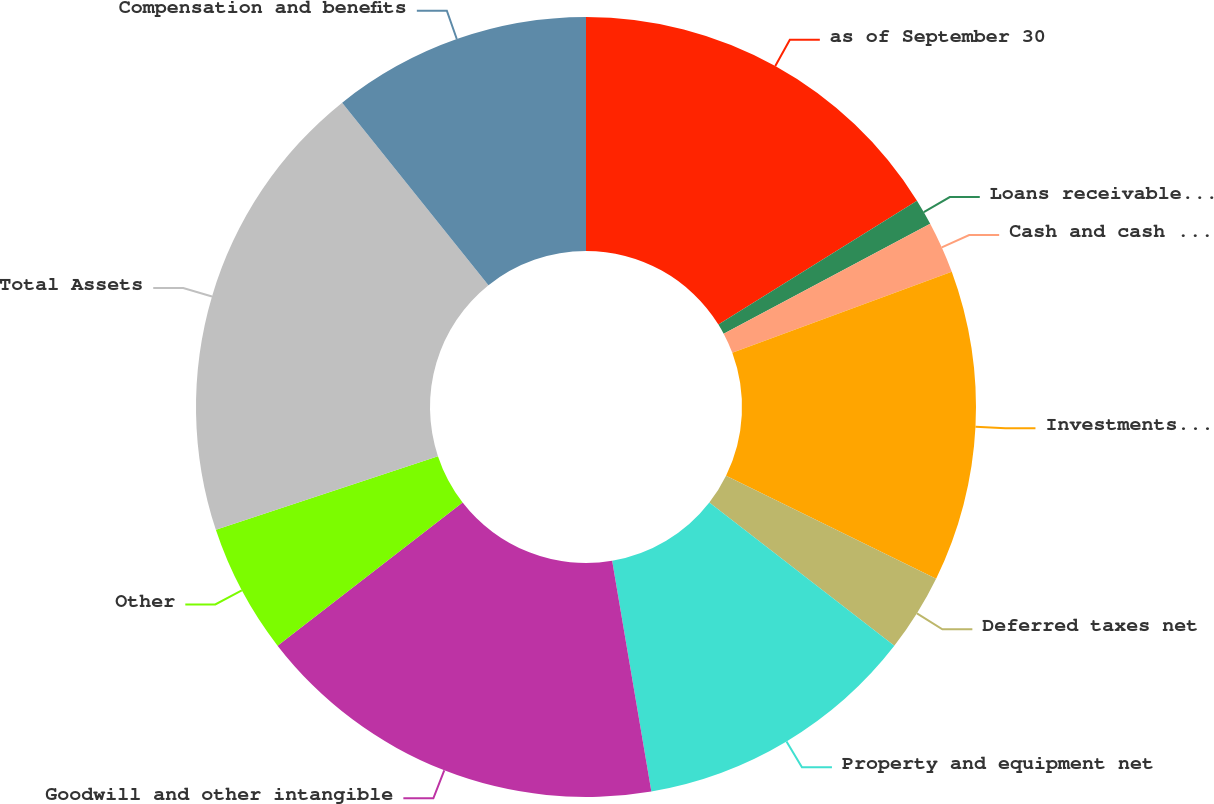<chart> <loc_0><loc_0><loc_500><loc_500><pie_chart><fcel>as of September 30<fcel>Loans receivable net Assets of<fcel>Cash and cash equivalents<fcel>Investments at fair value<fcel>Deferred taxes net<fcel>Property and equipment net<fcel>Goodwill and other intangible<fcel>Other<fcel>Total Assets<fcel>Compensation and benefits<nl><fcel>16.13%<fcel>1.08%<fcel>2.15%<fcel>12.9%<fcel>3.23%<fcel>11.83%<fcel>17.2%<fcel>5.38%<fcel>19.35%<fcel>10.75%<nl></chart> 